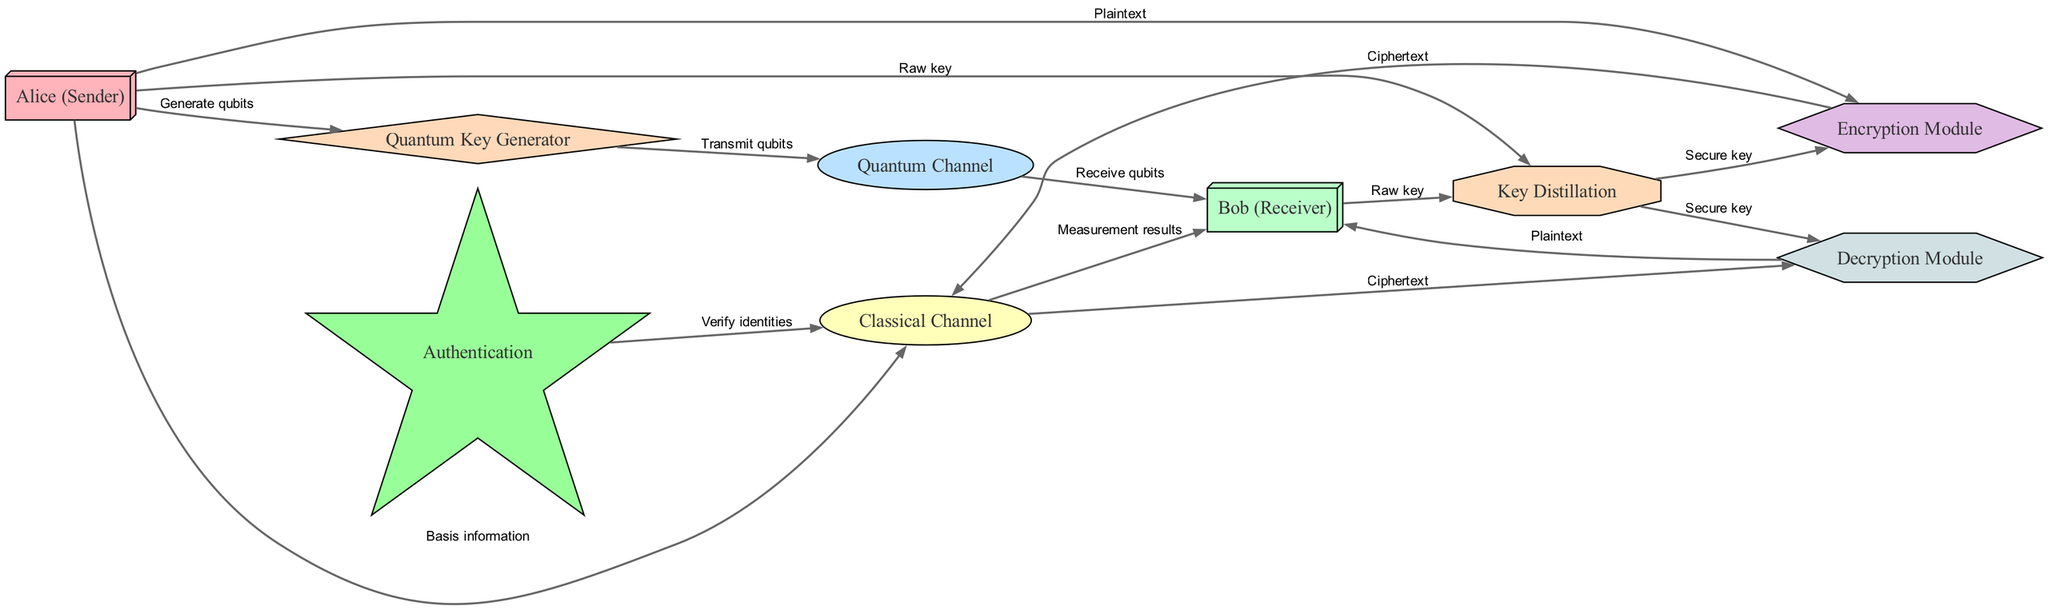What is the total number of nodes in the diagram? The diagram contains nine distinct nodes representing different entities in the secure communication system.
Answer: 9 What node initiates qubit generation? Alice (Sender) is the node that generates qubits by sending the appropriate signals to the Quantum Key Generator node.
Answer: Alice (Sender) Which channel is used for the transmission of qubits? The Quantum Channel is specifically designated for the transfer of qubits from Alice (Sender) to Bob (Receiver).
Answer: Quantum Channel What is the purpose of the Key Distillation node? The Key Distillation node combines raw keys obtained from both Alice and Bob to produce a secure key used for encryption and decryption.
Answer: Secure key How many paths lead from Alice (Sender) to the Classical Channel? There are two distinct paths leading from Alice to the Classical Channel: one for the transmission of basis information and the other for the delivery of plaintext.
Answer: 2 What is verified through the Authentication process? The Authentication node checks and verifies the identities of Alice and Bob to ensure secure communication before they exchange any keys or messages.
Answer: Identities Which module does Bob use to convert ciphertext back to plaintext? Bob utilizes the Decryption Module to decrypt the ciphertext received through the Classical Channel, which then yields the original plaintext message.
Answer: Decryption Module What is the relationship between the Quantum Key Generator and the Quantum Channel? The Quantum Key Generator transmits the qubits it generates to the Quantum Channel, which then facilitates the movement of these qubits to the receiver.
Answer: Transmit qubits What type of information is shared over the Classical Channel from Alice to Bob? Alice sends basis information and measurement results over the Classical Channel to Bob, which are crucial for the key generation process.
Answer: Basis information 